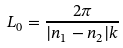Convert formula to latex. <formula><loc_0><loc_0><loc_500><loc_500>L _ { 0 } = \frac { 2 \pi } { | n _ { 1 } - n _ { 2 } | k }</formula> 